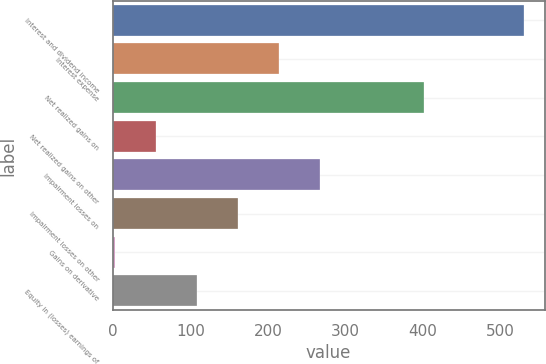<chart> <loc_0><loc_0><loc_500><loc_500><bar_chart><fcel>Interest and dividend income<fcel>Interest expense<fcel>Net realized gains on<fcel>Net realized gains on other<fcel>Impairment losses on<fcel>Impairment losses on other<fcel>Gains on derivative<fcel>Equity in (losses) earnings of<nl><fcel>530<fcel>213.8<fcel>401<fcel>55.7<fcel>266.5<fcel>161.1<fcel>3<fcel>108.4<nl></chart> 